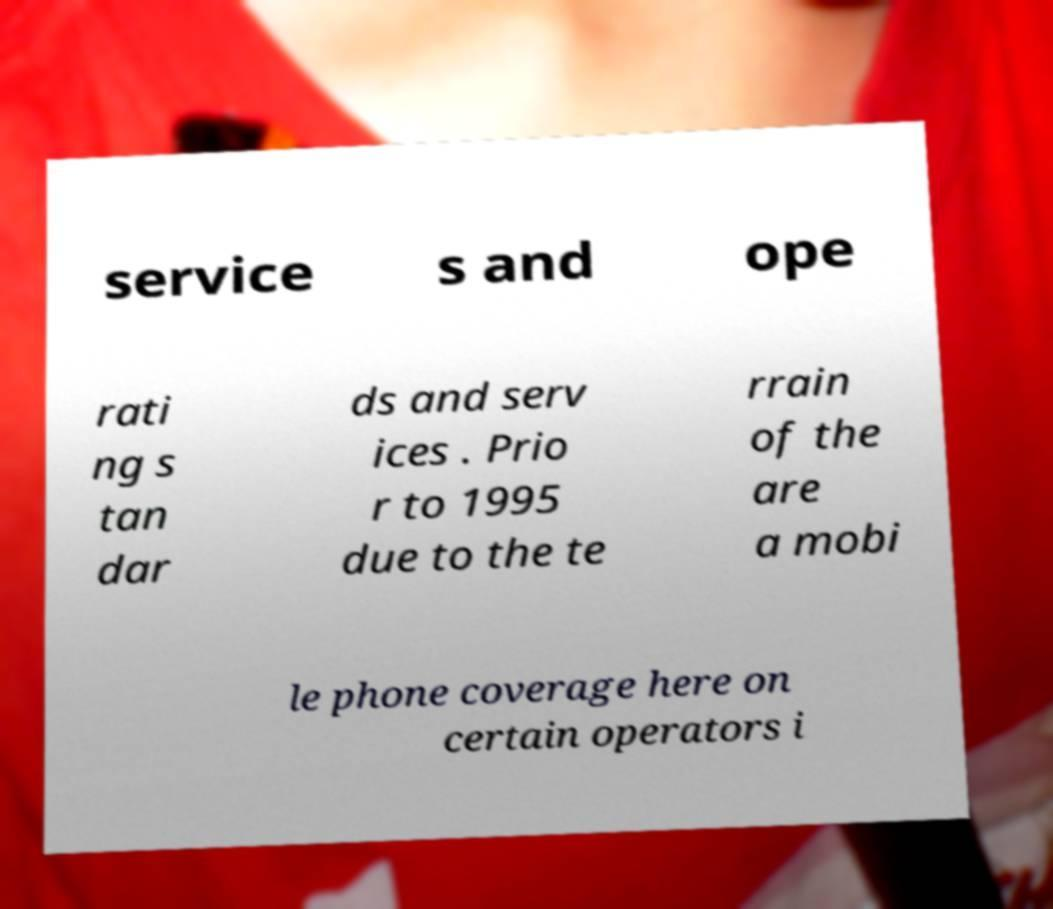There's text embedded in this image that I need extracted. Can you transcribe it verbatim? service s and ope rati ng s tan dar ds and serv ices . Prio r to 1995 due to the te rrain of the are a mobi le phone coverage here on certain operators i 